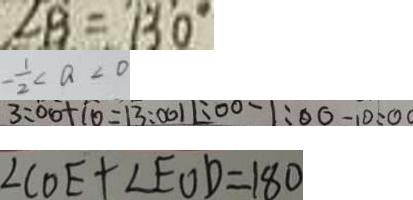<formula> <loc_0><loc_0><loc_500><loc_500>\angle B = 1 3 0 ^ { \circ } 
 - \frac { 1 } { 2 } < a < 0 
 3 : 0 0 + 1 0 = 1 3 : 0 0 1 1 : 0 0 - 1 : 0 0 = 1 0 : 0 0 
 \angle C O E + \angle E O D = 1 8 0</formula> 